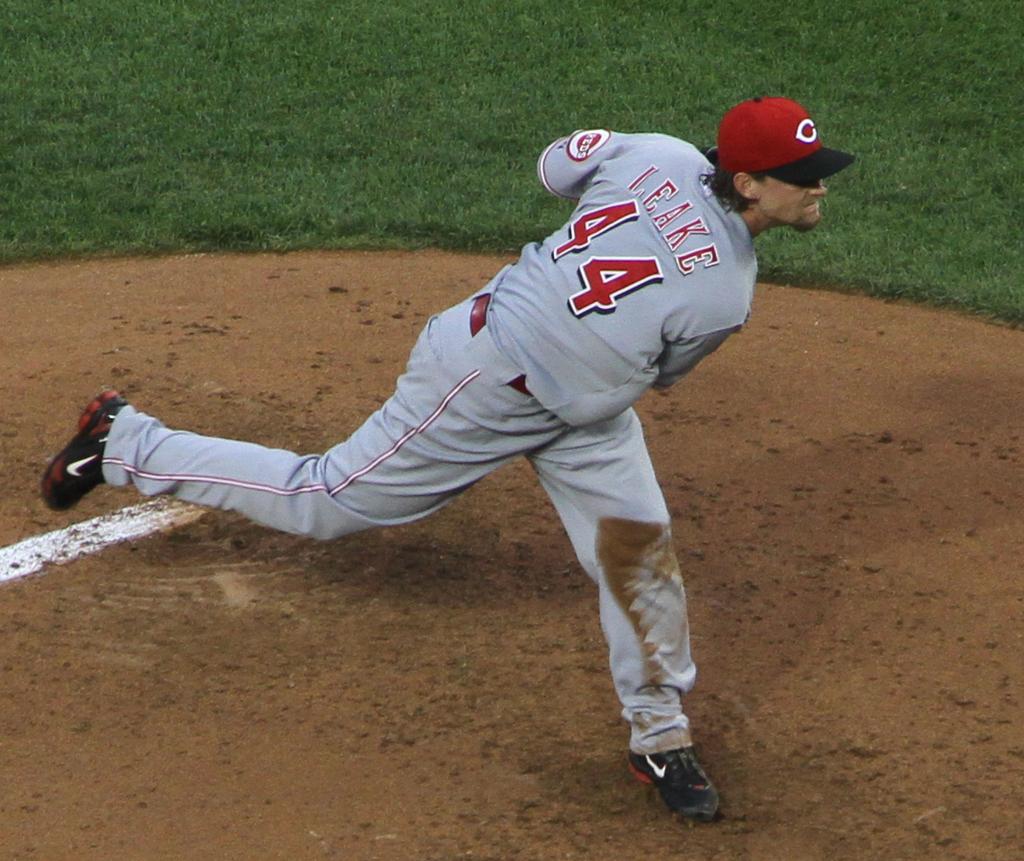What player number is throwing the ball?
Provide a short and direct response. 44. What is the name of the player?
Give a very brief answer. Leake. 